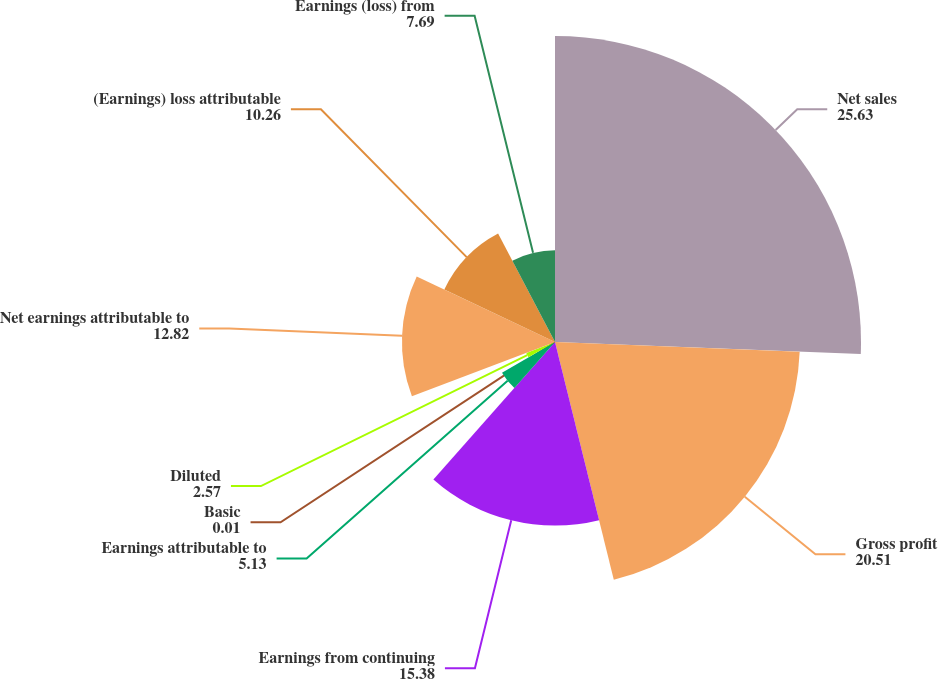Convert chart. <chart><loc_0><loc_0><loc_500><loc_500><pie_chart><fcel>Net sales<fcel>Gross profit<fcel>Earnings from continuing<fcel>Earnings attributable to<fcel>Basic<fcel>Diluted<fcel>Net earnings attributable to<fcel>(Earnings) loss attributable<fcel>Earnings (loss) from<nl><fcel>25.63%<fcel>20.51%<fcel>15.38%<fcel>5.13%<fcel>0.01%<fcel>2.57%<fcel>12.82%<fcel>10.26%<fcel>7.69%<nl></chart> 